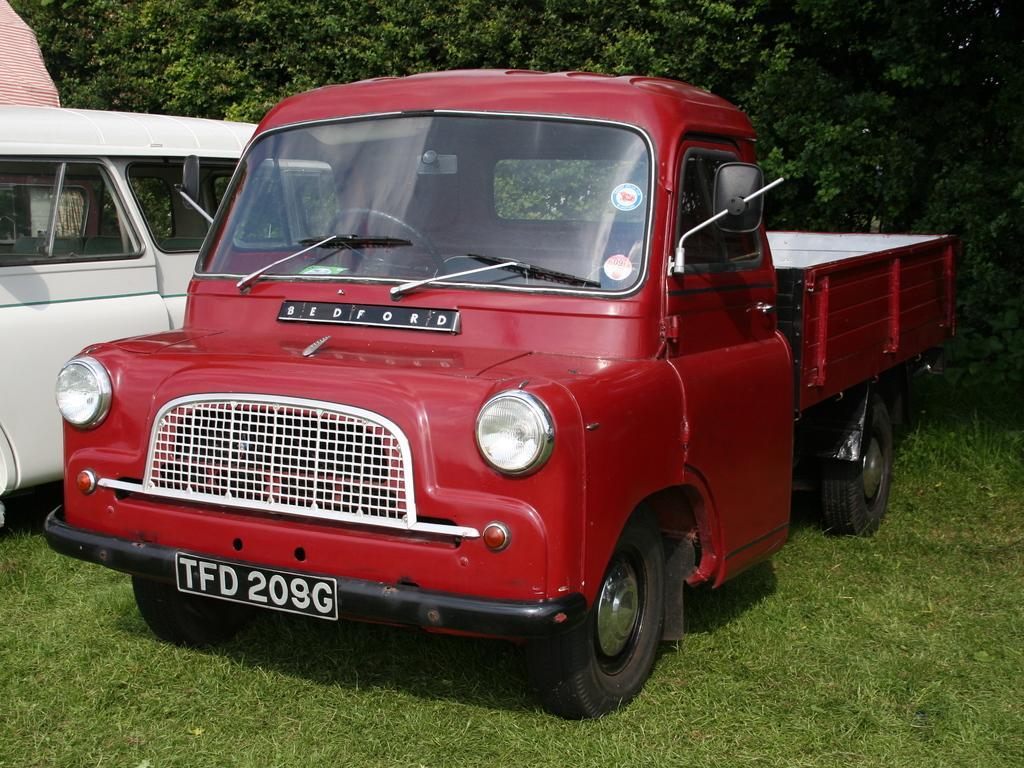What is present on the ground in the image? There are vehicles on the ground in the image. Can you describe one of the vehicles in the image? One of the vehicles is red in color. What can be seen in the background of the image? There are trees and grass visible in the background of the image. Where is the uncle standing with his rifle in the image? There is no uncle or rifle present in the image. 